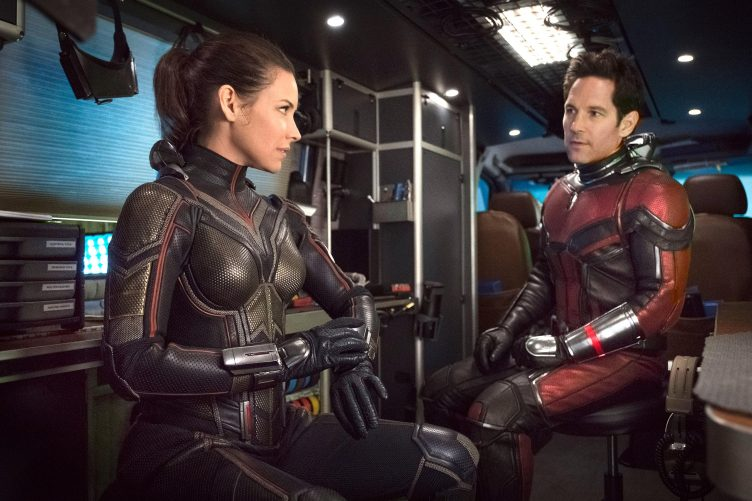Can you describe the technological environment surrounding the characters? The environment around the characters is distinctly futuristic and technologically advanced, featuring an array of electronic panels and ambient lighting that shifts between blue and orange hues. This setting likely represents a vehicle or a control room equipped with sophisticated tools and interfaces reflecting cutting-edge technology typical of the film's high-tech theme. The detailed design and lighting effects contribute to a sense of urgency and high stakes typically associated with their heroic endeavors. 